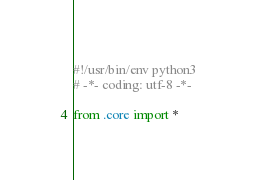Convert code to text. <code><loc_0><loc_0><loc_500><loc_500><_Python_>#!/usr/bin/env python3
# -*- coding: utf-8 -*-

from .core import *</code> 